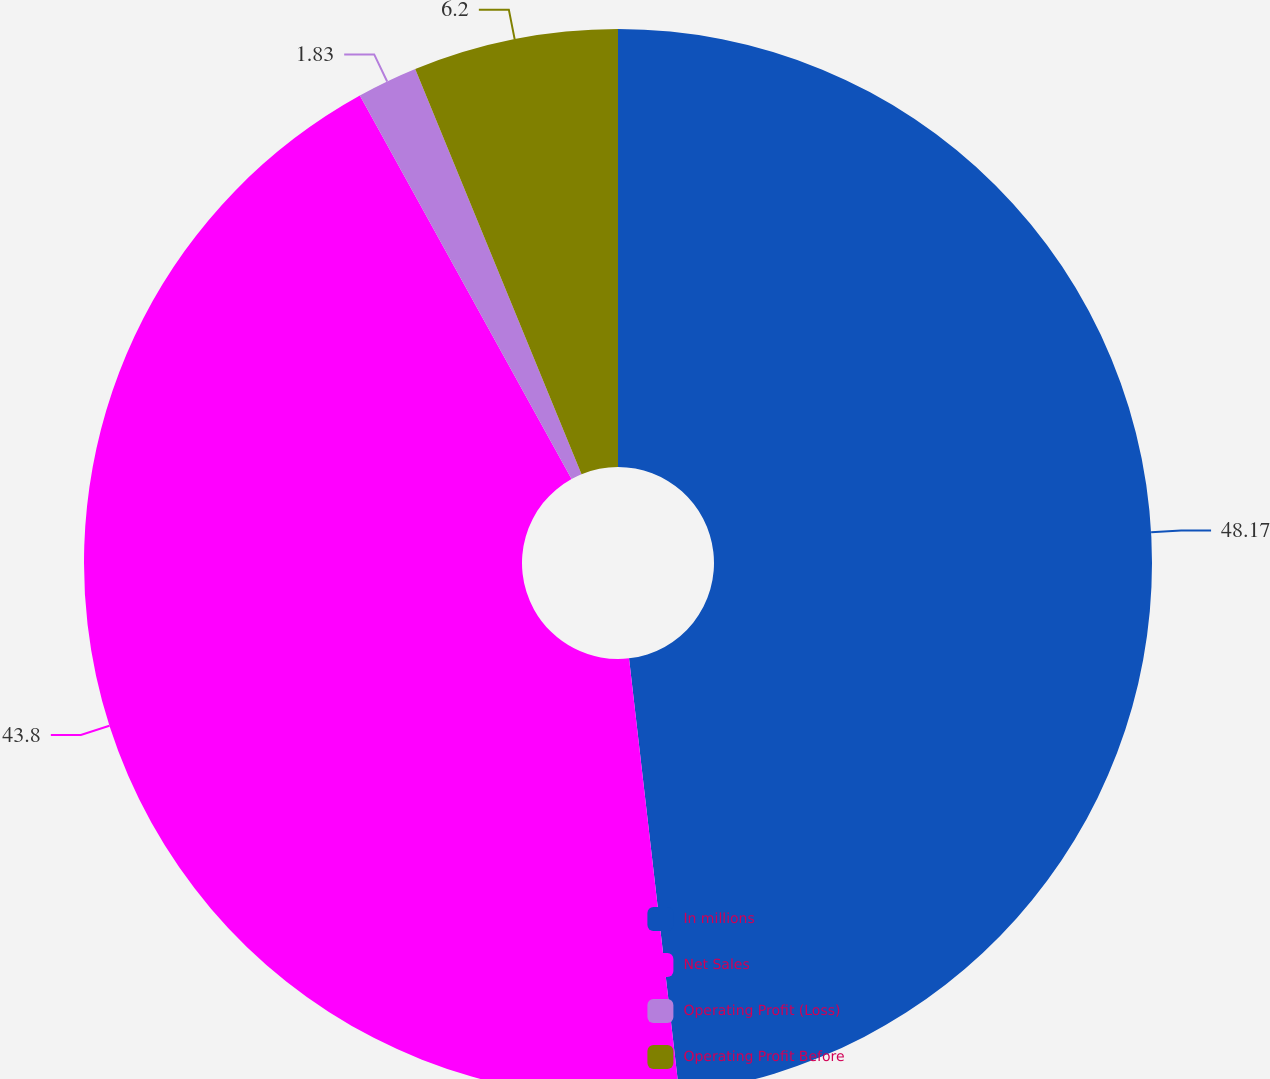Convert chart to OTSL. <chart><loc_0><loc_0><loc_500><loc_500><pie_chart><fcel>In millions<fcel>Net Sales<fcel>Operating Profit (Loss)<fcel>Operating Profit Before<nl><fcel>48.17%<fcel>43.8%<fcel>1.83%<fcel>6.2%<nl></chart> 